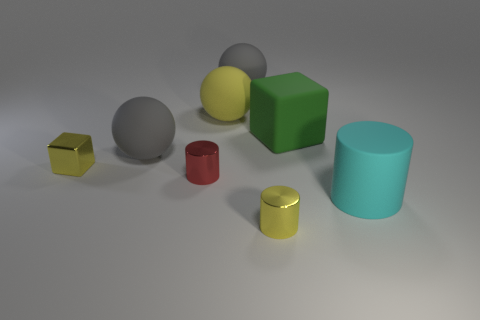Subtract all small metallic cylinders. How many cylinders are left? 1 Subtract all red cubes. How many gray balls are left? 2 Add 2 big rubber spheres. How many objects exist? 10 Subtract 1 cubes. How many cubes are left? 1 Subtract all spheres. How many objects are left? 5 Add 5 gray metallic balls. How many gray metallic balls exist? 5 Subtract 0 red spheres. How many objects are left? 8 Subtract all brown cylinders. Subtract all cyan cubes. How many cylinders are left? 3 Subtract all large blue metal cylinders. Subtract all small yellow metallic blocks. How many objects are left? 7 Add 6 green rubber objects. How many green rubber objects are left? 7 